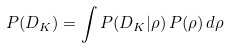<formula> <loc_0><loc_0><loc_500><loc_500>P ( D _ { K } ) = \int P ( D _ { K } | \rho ) \, P ( \rho ) \, d \rho</formula> 